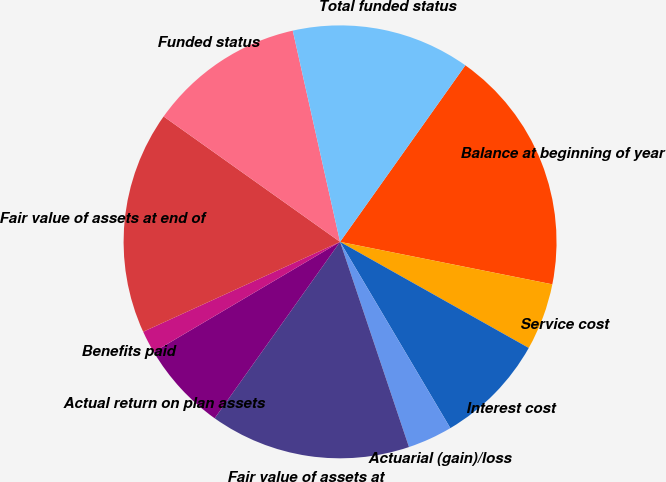<chart> <loc_0><loc_0><loc_500><loc_500><pie_chart><fcel>Balance at beginning of year<fcel>Service cost<fcel>Interest cost<fcel>Actuarial (gain)/loss<fcel>Fair value of assets at<fcel>Actual return on plan assets<fcel>Benefits paid<fcel>Fair value of assets at end of<fcel>Funded status<fcel>Total funded status<nl><fcel>18.32%<fcel>5.01%<fcel>8.34%<fcel>3.35%<fcel>14.99%<fcel>6.67%<fcel>1.68%<fcel>16.65%<fcel>11.66%<fcel>13.33%<nl></chart> 